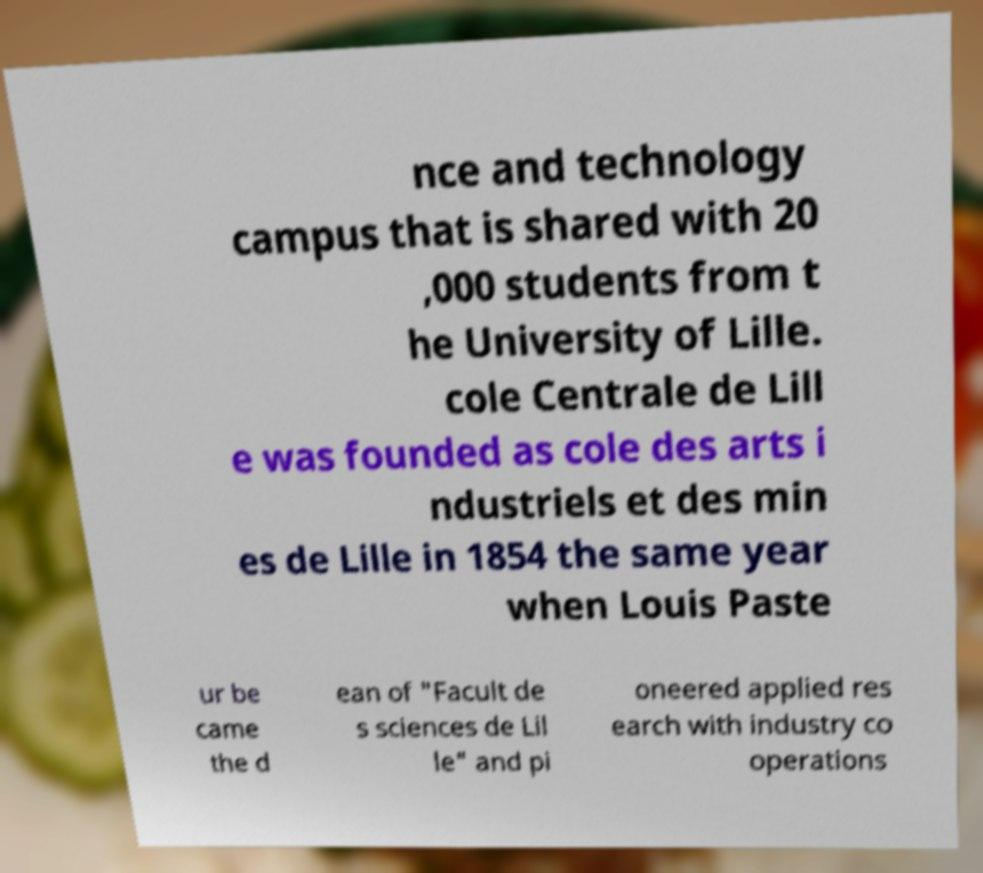Could you extract and type out the text from this image? nce and technology campus that is shared with 20 ,000 students from t he University of Lille. cole Centrale de Lill e was founded as cole des arts i ndustriels et des min es de Lille in 1854 the same year when Louis Paste ur be came the d ean of "Facult de s sciences de Lil le" and pi oneered applied res earch with industry co operations 